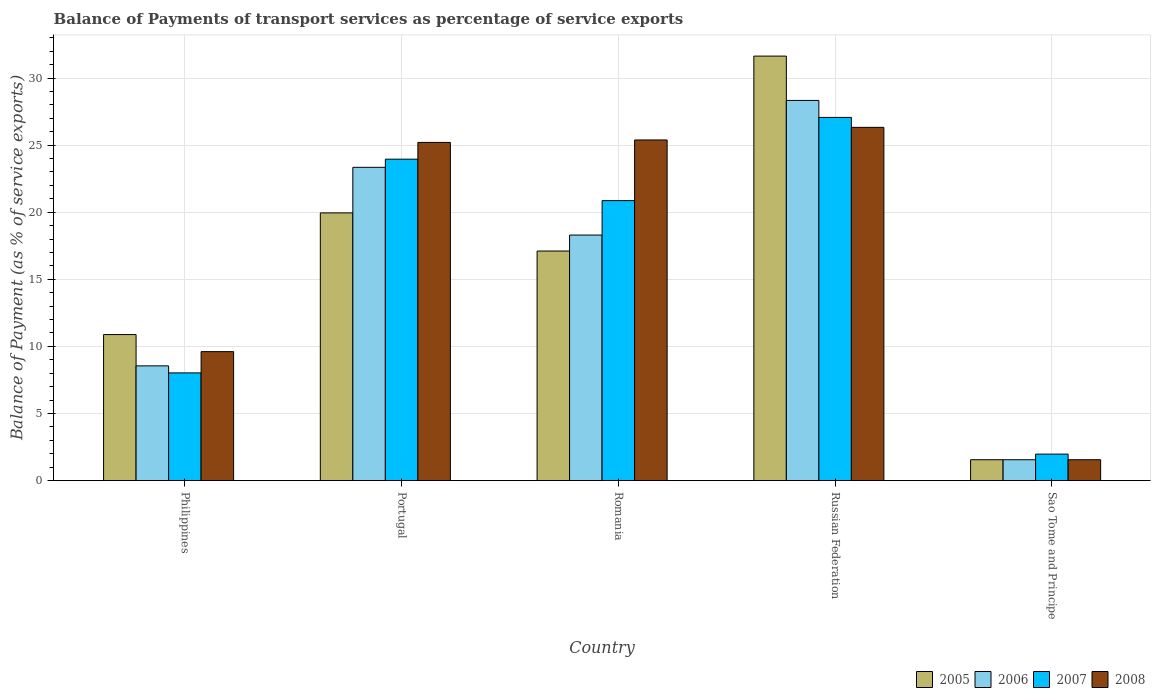How many different coloured bars are there?
Keep it short and to the point. 4. How many groups of bars are there?
Offer a very short reply. 5. How many bars are there on the 5th tick from the left?
Make the answer very short. 4. How many bars are there on the 1st tick from the right?
Offer a terse response. 4. What is the label of the 2nd group of bars from the left?
Offer a very short reply. Portugal. What is the balance of payments of transport services in 2007 in Russian Federation?
Ensure brevity in your answer.  27.06. Across all countries, what is the maximum balance of payments of transport services in 2006?
Make the answer very short. 28.33. Across all countries, what is the minimum balance of payments of transport services in 2006?
Your response must be concise. 1.55. In which country was the balance of payments of transport services in 2006 maximum?
Keep it short and to the point. Russian Federation. In which country was the balance of payments of transport services in 2005 minimum?
Provide a short and direct response. Sao Tome and Principe. What is the total balance of payments of transport services in 2007 in the graph?
Your answer should be compact. 81.87. What is the difference between the balance of payments of transport services in 2007 in Philippines and that in Russian Federation?
Offer a very short reply. -19.04. What is the difference between the balance of payments of transport services in 2007 in Portugal and the balance of payments of transport services in 2008 in Russian Federation?
Provide a short and direct response. -2.37. What is the average balance of payments of transport services in 2006 per country?
Your answer should be very brief. 16.01. What is the difference between the balance of payments of transport services of/in 2008 and balance of payments of transport services of/in 2006 in Sao Tome and Principe?
Your answer should be compact. 1.664999249584298e-10. What is the ratio of the balance of payments of transport services in 2007 in Portugal to that in Russian Federation?
Give a very brief answer. 0.89. Is the difference between the balance of payments of transport services in 2008 in Romania and Russian Federation greater than the difference between the balance of payments of transport services in 2006 in Romania and Russian Federation?
Keep it short and to the point. Yes. What is the difference between the highest and the second highest balance of payments of transport services in 2005?
Your response must be concise. -2.84. What is the difference between the highest and the lowest balance of payments of transport services in 2006?
Provide a succinct answer. 26.77. Is the sum of the balance of payments of transport services in 2006 in Portugal and Russian Federation greater than the maximum balance of payments of transport services in 2005 across all countries?
Your response must be concise. Yes. Is it the case that in every country, the sum of the balance of payments of transport services in 2007 and balance of payments of transport services in 2008 is greater than the sum of balance of payments of transport services in 2006 and balance of payments of transport services in 2005?
Provide a succinct answer. No. Is it the case that in every country, the sum of the balance of payments of transport services in 2005 and balance of payments of transport services in 2008 is greater than the balance of payments of transport services in 2006?
Ensure brevity in your answer.  Yes. How many bars are there?
Provide a short and direct response. 20. Are all the bars in the graph horizontal?
Keep it short and to the point. No. How many countries are there in the graph?
Keep it short and to the point. 5. Are the values on the major ticks of Y-axis written in scientific E-notation?
Make the answer very short. No. Does the graph contain any zero values?
Your response must be concise. No. How many legend labels are there?
Your answer should be compact. 4. How are the legend labels stacked?
Your response must be concise. Horizontal. What is the title of the graph?
Your response must be concise. Balance of Payments of transport services as percentage of service exports. What is the label or title of the Y-axis?
Keep it short and to the point. Balance of Payment (as % of service exports). What is the Balance of Payment (as % of service exports) of 2005 in Philippines?
Keep it short and to the point. 10.88. What is the Balance of Payment (as % of service exports) of 2006 in Philippines?
Give a very brief answer. 8.55. What is the Balance of Payment (as % of service exports) in 2007 in Philippines?
Your answer should be compact. 8.02. What is the Balance of Payment (as % of service exports) in 2008 in Philippines?
Give a very brief answer. 9.61. What is the Balance of Payment (as % of service exports) of 2005 in Portugal?
Your response must be concise. 19.95. What is the Balance of Payment (as % of service exports) of 2006 in Portugal?
Offer a very short reply. 23.34. What is the Balance of Payment (as % of service exports) of 2007 in Portugal?
Your answer should be compact. 23.95. What is the Balance of Payment (as % of service exports) in 2008 in Portugal?
Give a very brief answer. 25.2. What is the Balance of Payment (as % of service exports) in 2005 in Romania?
Provide a succinct answer. 17.11. What is the Balance of Payment (as % of service exports) of 2006 in Romania?
Give a very brief answer. 18.3. What is the Balance of Payment (as % of service exports) in 2007 in Romania?
Make the answer very short. 20.86. What is the Balance of Payment (as % of service exports) of 2008 in Romania?
Your answer should be compact. 25.38. What is the Balance of Payment (as % of service exports) in 2005 in Russian Federation?
Give a very brief answer. 31.63. What is the Balance of Payment (as % of service exports) of 2006 in Russian Federation?
Provide a succinct answer. 28.33. What is the Balance of Payment (as % of service exports) in 2007 in Russian Federation?
Your answer should be very brief. 27.06. What is the Balance of Payment (as % of service exports) in 2008 in Russian Federation?
Your answer should be very brief. 26.32. What is the Balance of Payment (as % of service exports) of 2005 in Sao Tome and Principe?
Offer a very short reply. 1.55. What is the Balance of Payment (as % of service exports) in 2006 in Sao Tome and Principe?
Your answer should be very brief. 1.55. What is the Balance of Payment (as % of service exports) of 2007 in Sao Tome and Principe?
Offer a very short reply. 1.97. What is the Balance of Payment (as % of service exports) of 2008 in Sao Tome and Principe?
Make the answer very short. 1.55. Across all countries, what is the maximum Balance of Payment (as % of service exports) of 2005?
Your response must be concise. 31.63. Across all countries, what is the maximum Balance of Payment (as % of service exports) of 2006?
Ensure brevity in your answer.  28.33. Across all countries, what is the maximum Balance of Payment (as % of service exports) in 2007?
Your answer should be compact. 27.06. Across all countries, what is the maximum Balance of Payment (as % of service exports) in 2008?
Your response must be concise. 26.32. Across all countries, what is the minimum Balance of Payment (as % of service exports) of 2005?
Your response must be concise. 1.55. Across all countries, what is the minimum Balance of Payment (as % of service exports) in 2006?
Make the answer very short. 1.55. Across all countries, what is the minimum Balance of Payment (as % of service exports) in 2007?
Offer a terse response. 1.97. Across all countries, what is the minimum Balance of Payment (as % of service exports) in 2008?
Provide a succinct answer. 1.55. What is the total Balance of Payment (as % of service exports) of 2005 in the graph?
Keep it short and to the point. 81.12. What is the total Balance of Payment (as % of service exports) of 2006 in the graph?
Provide a short and direct response. 80.07. What is the total Balance of Payment (as % of service exports) of 2007 in the graph?
Provide a short and direct response. 81.87. What is the total Balance of Payment (as % of service exports) of 2008 in the graph?
Your answer should be very brief. 88.07. What is the difference between the Balance of Payment (as % of service exports) in 2005 in Philippines and that in Portugal?
Offer a very short reply. -9.07. What is the difference between the Balance of Payment (as % of service exports) in 2006 in Philippines and that in Portugal?
Ensure brevity in your answer.  -14.8. What is the difference between the Balance of Payment (as % of service exports) in 2007 in Philippines and that in Portugal?
Give a very brief answer. -15.93. What is the difference between the Balance of Payment (as % of service exports) in 2008 in Philippines and that in Portugal?
Ensure brevity in your answer.  -15.59. What is the difference between the Balance of Payment (as % of service exports) of 2005 in Philippines and that in Romania?
Offer a very short reply. -6.23. What is the difference between the Balance of Payment (as % of service exports) of 2006 in Philippines and that in Romania?
Offer a very short reply. -9.75. What is the difference between the Balance of Payment (as % of service exports) in 2007 in Philippines and that in Romania?
Your response must be concise. -12.84. What is the difference between the Balance of Payment (as % of service exports) in 2008 in Philippines and that in Romania?
Ensure brevity in your answer.  -15.77. What is the difference between the Balance of Payment (as % of service exports) of 2005 in Philippines and that in Russian Federation?
Your response must be concise. -20.75. What is the difference between the Balance of Payment (as % of service exports) in 2006 in Philippines and that in Russian Federation?
Offer a terse response. -19.78. What is the difference between the Balance of Payment (as % of service exports) in 2007 in Philippines and that in Russian Federation?
Give a very brief answer. -19.04. What is the difference between the Balance of Payment (as % of service exports) in 2008 in Philippines and that in Russian Federation?
Your answer should be very brief. -16.71. What is the difference between the Balance of Payment (as % of service exports) in 2005 in Philippines and that in Sao Tome and Principe?
Offer a terse response. 9.33. What is the difference between the Balance of Payment (as % of service exports) of 2006 in Philippines and that in Sao Tome and Principe?
Your answer should be compact. 6.99. What is the difference between the Balance of Payment (as % of service exports) in 2007 in Philippines and that in Sao Tome and Principe?
Your response must be concise. 6.05. What is the difference between the Balance of Payment (as % of service exports) of 2008 in Philippines and that in Sao Tome and Principe?
Your answer should be compact. 8.06. What is the difference between the Balance of Payment (as % of service exports) in 2005 in Portugal and that in Romania?
Ensure brevity in your answer.  2.84. What is the difference between the Balance of Payment (as % of service exports) of 2006 in Portugal and that in Romania?
Your answer should be very brief. 5.05. What is the difference between the Balance of Payment (as % of service exports) of 2007 in Portugal and that in Romania?
Make the answer very short. 3.09. What is the difference between the Balance of Payment (as % of service exports) of 2008 in Portugal and that in Romania?
Provide a short and direct response. -0.18. What is the difference between the Balance of Payment (as % of service exports) of 2005 in Portugal and that in Russian Federation?
Keep it short and to the point. -11.68. What is the difference between the Balance of Payment (as % of service exports) in 2006 in Portugal and that in Russian Federation?
Provide a short and direct response. -4.98. What is the difference between the Balance of Payment (as % of service exports) in 2007 in Portugal and that in Russian Federation?
Offer a terse response. -3.11. What is the difference between the Balance of Payment (as % of service exports) in 2008 in Portugal and that in Russian Federation?
Your response must be concise. -1.12. What is the difference between the Balance of Payment (as % of service exports) of 2005 in Portugal and that in Sao Tome and Principe?
Your response must be concise. 18.39. What is the difference between the Balance of Payment (as % of service exports) in 2006 in Portugal and that in Sao Tome and Principe?
Offer a terse response. 21.79. What is the difference between the Balance of Payment (as % of service exports) in 2007 in Portugal and that in Sao Tome and Principe?
Give a very brief answer. 21.98. What is the difference between the Balance of Payment (as % of service exports) in 2008 in Portugal and that in Sao Tome and Principe?
Provide a succinct answer. 23.65. What is the difference between the Balance of Payment (as % of service exports) in 2005 in Romania and that in Russian Federation?
Your response must be concise. -14.53. What is the difference between the Balance of Payment (as % of service exports) of 2006 in Romania and that in Russian Federation?
Make the answer very short. -10.03. What is the difference between the Balance of Payment (as % of service exports) in 2007 in Romania and that in Russian Federation?
Ensure brevity in your answer.  -6.2. What is the difference between the Balance of Payment (as % of service exports) in 2008 in Romania and that in Russian Federation?
Offer a terse response. -0.94. What is the difference between the Balance of Payment (as % of service exports) of 2005 in Romania and that in Sao Tome and Principe?
Give a very brief answer. 15.55. What is the difference between the Balance of Payment (as % of service exports) of 2006 in Romania and that in Sao Tome and Principe?
Your response must be concise. 16.74. What is the difference between the Balance of Payment (as % of service exports) in 2007 in Romania and that in Sao Tome and Principe?
Ensure brevity in your answer.  18.89. What is the difference between the Balance of Payment (as % of service exports) in 2008 in Romania and that in Sao Tome and Principe?
Give a very brief answer. 23.83. What is the difference between the Balance of Payment (as % of service exports) of 2005 in Russian Federation and that in Sao Tome and Principe?
Provide a short and direct response. 30.08. What is the difference between the Balance of Payment (as % of service exports) of 2006 in Russian Federation and that in Sao Tome and Principe?
Make the answer very short. 26.77. What is the difference between the Balance of Payment (as % of service exports) in 2007 in Russian Federation and that in Sao Tome and Principe?
Keep it short and to the point. 25.09. What is the difference between the Balance of Payment (as % of service exports) in 2008 in Russian Federation and that in Sao Tome and Principe?
Provide a short and direct response. 24.77. What is the difference between the Balance of Payment (as % of service exports) in 2005 in Philippines and the Balance of Payment (as % of service exports) in 2006 in Portugal?
Ensure brevity in your answer.  -12.46. What is the difference between the Balance of Payment (as % of service exports) of 2005 in Philippines and the Balance of Payment (as % of service exports) of 2007 in Portugal?
Offer a terse response. -13.07. What is the difference between the Balance of Payment (as % of service exports) in 2005 in Philippines and the Balance of Payment (as % of service exports) in 2008 in Portugal?
Provide a short and direct response. -14.32. What is the difference between the Balance of Payment (as % of service exports) in 2006 in Philippines and the Balance of Payment (as % of service exports) in 2007 in Portugal?
Make the answer very short. -15.4. What is the difference between the Balance of Payment (as % of service exports) in 2006 in Philippines and the Balance of Payment (as % of service exports) in 2008 in Portugal?
Your answer should be very brief. -16.65. What is the difference between the Balance of Payment (as % of service exports) of 2007 in Philippines and the Balance of Payment (as % of service exports) of 2008 in Portugal?
Your response must be concise. -17.18. What is the difference between the Balance of Payment (as % of service exports) of 2005 in Philippines and the Balance of Payment (as % of service exports) of 2006 in Romania?
Your response must be concise. -7.42. What is the difference between the Balance of Payment (as % of service exports) of 2005 in Philippines and the Balance of Payment (as % of service exports) of 2007 in Romania?
Offer a very short reply. -9.98. What is the difference between the Balance of Payment (as % of service exports) of 2005 in Philippines and the Balance of Payment (as % of service exports) of 2008 in Romania?
Provide a short and direct response. -14.5. What is the difference between the Balance of Payment (as % of service exports) in 2006 in Philippines and the Balance of Payment (as % of service exports) in 2007 in Romania?
Keep it short and to the point. -12.32. What is the difference between the Balance of Payment (as % of service exports) of 2006 in Philippines and the Balance of Payment (as % of service exports) of 2008 in Romania?
Your answer should be very brief. -16.84. What is the difference between the Balance of Payment (as % of service exports) of 2007 in Philippines and the Balance of Payment (as % of service exports) of 2008 in Romania?
Offer a very short reply. -17.36. What is the difference between the Balance of Payment (as % of service exports) of 2005 in Philippines and the Balance of Payment (as % of service exports) of 2006 in Russian Federation?
Provide a short and direct response. -17.45. What is the difference between the Balance of Payment (as % of service exports) in 2005 in Philippines and the Balance of Payment (as % of service exports) in 2007 in Russian Federation?
Offer a terse response. -16.18. What is the difference between the Balance of Payment (as % of service exports) of 2005 in Philippines and the Balance of Payment (as % of service exports) of 2008 in Russian Federation?
Offer a very short reply. -15.44. What is the difference between the Balance of Payment (as % of service exports) in 2006 in Philippines and the Balance of Payment (as % of service exports) in 2007 in Russian Federation?
Provide a succinct answer. -18.51. What is the difference between the Balance of Payment (as % of service exports) in 2006 in Philippines and the Balance of Payment (as % of service exports) in 2008 in Russian Federation?
Offer a terse response. -17.77. What is the difference between the Balance of Payment (as % of service exports) of 2007 in Philippines and the Balance of Payment (as % of service exports) of 2008 in Russian Federation?
Keep it short and to the point. -18.3. What is the difference between the Balance of Payment (as % of service exports) of 2005 in Philippines and the Balance of Payment (as % of service exports) of 2006 in Sao Tome and Principe?
Offer a terse response. 9.33. What is the difference between the Balance of Payment (as % of service exports) in 2005 in Philippines and the Balance of Payment (as % of service exports) in 2007 in Sao Tome and Principe?
Offer a terse response. 8.91. What is the difference between the Balance of Payment (as % of service exports) in 2005 in Philippines and the Balance of Payment (as % of service exports) in 2008 in Sao Tome and Principe?
Your answer should be very brief. 9.33. What is the difference between the Balance of Payment (as % of service exports) of 2006 in Philippines and the Balance of Payment (as % of service exports) of 2007 in Sao Tome and Principe?
Offer a very short reply. 6.58. What is the difference between the Balance of Payment (as % of service exports) of 2006 in Philippines and the Balance of Payment (as % of service exports) of 2008 in Sao Tome and Principe?
Keep it short and to the point. 6.99. What is the difference between the Balance of Payment (as % of service exports) of 2007 in Philippines and the Balance of Payment (as % of service exports) of 2008 in Sao Tome and Principe?
Keep it short and to the point. 6.47. What is the difference between the Balance of Payment (as % of service exports) in 2005 in Portugal and the Balance of Payment (as % of service exports) in 2006 in Romania?
Your answer should be very brief. 1.65. What is the difference between the Balance of Payment (as % of service exports) in 2005 in Portugal and the Balance of Payment (as % of service exports) in 2007 in Romania?
Your answer should be compact. -0.91. What is the difference between the Balance of Payment (as % of service exports) of 2005 in Portugal and the Balance of Payment (as % of service exports) of 2008 in Romania?
Make the answer very short. -5.43. What is the difference between the Balance of Payment (as % of service exports) in 2006 in Portugal and the Balance of Payment (as % of service exports) in 2007 in Romania?
Give a very brief answer. 2.48. What is the difference between the Balance of Payment (as % of service exports) of 2006 in Portugal and the Balance of Payment (as % of service exports) of 2008 in Romania?
Offer a very short reply. -2.04. What is the difference between the Balance of Payment (as % of service exports) of 2007 in Portugal and the Balance of Payment (as % of service exports) of 2008 in Romania?
Offer a terse response. -1.43. What is the difference between the Balance of Payment (as % of service exports) in 2005 in Portugal and the Balance of Payment (as % of service exports) in 2006 in Russian Federation?
Give a very brief answer. -8.38. What is the difference between the Balance of Payment (as % of service exports) in 2005 in Portugal and the Balance of Payment (as % of service exports) in 2007 in Russian Federation?
Provide a succinct answer. -7.11. What is the difference between the Balance of Payment (as % of service exports) of 2005 in Portugal and the Balance of Payment (as % of service exports) of 2008 in Russian Federation?
Give a very brief answer. -6.37. What is the difference between the Balance of Payment (as % of service exports) of 2006 in Portugal and the Balance of Payment (as % of service exports) of 2007 in Russian Federation?
Provide a short and direct response. -3.72. What is the difference between the Balance of Payment (as % of service exports) of 2006 in Portugal and the Balance of Payment (as % of service exports) of 2008 in Russian Federation?
Provide a short and direct response. -2.98. What is the difference between the Balance of Payment (as % of service exports) of 2007 in Portugal and the Balance of Payment (as % of service exports) of 2008 in Russian Federation?
Provide a short and direct response. -2.37. What is the difference between the Balance of Payment (as % of service exports) in 2005 in Portugal and the Balance of Payment (as % of service exports) in 2006 in Sao Tome and Principe?
Your answer should be very brief. 18.39. What is the difference between the Balance of Payment (as % of service exports) in 2005 in Portugal and the Balance of Payment (as % of service exports) in 2007 in Sao Tome and Principe?
Your answer should be very brief. 17.98. What is the difference between the Balance of Payment (as % of service exports) in 2005 in Portugal and the Balance of Payment (as % of service exports) in 2008 in Sao Tome and Principe?
Give a very brief answer. 18.39. What is the difference between the Balance of Payment (as % of service exports) of 2006 in Portugal and the Balance of Payment (as % of service exports) of 2007 in Sao Tome and Principe?
Make the answer very short. 21.37. What is the difference between the Balance of Payment (as % of service exports) of 2006 in Portugal and the Balance of Payment (as % of service exports) of 2008 in Sao Tome and Principe?
Your answer should be compact. 21.79. What is the difference between the Balance of Payment (as % of service exports) in 2007 in Portugal and the Balance of Payment (as % of service exports) in 2008 in Sao Tome and Principe?
Offer a very short reply. 22.4. What is the difference between the Balance of Payment (as % of service exports) in 2005 in Romania and the Balance of Payment (as % of service exports) in 2006 in Russian Federation?
Keep it short and to the point. -11.22. What is the difference between the Balance of Payment (as % of service exports) in 2005 in Romania and the Balance of Payment (as % of service exports) in 2007 in Russian Federation?
Make the answer very short. -9.96. What is the difference between the Balance of Payment (as % of service exports) in 2005 in Romania and the Balance of Payment (as % of service exports) in 2008 in Russian Federation?
Provide a short and direct response. -9.22. What is the difference between the Balance of Payment (as % of service exports) of 2006 in Romania and the Balance of Payment (as % of service exports) of 2007 in Russian Federation?
Make the answer very short. -8.77. What is the difference between the Balance of Payment (as % of service exports) of 2006 in Romania and the Balance of Payment (as % of service exports) of 2008 in Russian Federation?
Your answer should be compact. -8.03. What is the difference between the Balance of Payment (as % of service exports) of 2007 in Romania and the Balance of Payment (as % of service exports) of 2008 in Russian Federation?
Ensure brevity in your answer.  -5.46. What is the difference between the Balance of Payment (as % of service exports) of 2005 in Romania and the Balance of Payment (as % of service exports) of 2006 in Sao Tome and Principe?
Provide a short and direct response. 15.55. What is the difference between the Balance of Payment (as % of service exports) in 2005 in Romania and the Balance of Payment (as % of service exports) in 2007 in Sao Tome and Principe?
Your answer should be very brief. 15.14. What is the difference between the Balance of Payment (as % of service exports) in 2005 in Romania and the Balance of Payment (as % of service exports) in 2008 in Sao Tome and Principe?
Your response must be concise. 15.55. What is the difference between the Balance of Payment (as % of service exports) in 2006 in Romania and the Balance of Payment (as % of service exports) in 2007 in Sao Tome and Principe?
Provide a short and direct response. 16.32. What is the difference between the Balance of Payment (as % of service exports) of 2006 in Romania and the Balance of Payment (as % of service exports) of 2008 in Sao Tome and Principe?
Offer a very short reply. 16.74. What is the difference between the Balance of Payment (as % of service exports) in 2007 in Romania and the Balance of Payment (as % of service exports) in 2008 in Sao Tome and Principe?
Offer a terse response. 19.31. What is the difference between the Balance of Payment (as % of service exports) of 2005 in Russian Federation and the Balance of Payment (as % of service exports) of 2006 in Sao Tome and Principe?
Ensure brevity in your answer.  30.08. What is the difference between the Balance of Payment (as % of service exports) in 2005 in Russian Federation and the Balance of Payment (as % of service exports) in 2007 in Sao Tome and Principe?
Your response must be concise. 29.66. What is the difference between the Balance of Payment (as % of service exports) in 2005 in Russian Federation and the Balance of Payment (as % of service exports) in 2008 in Sao Tome and Principe?
Provide a succinct answer. 30.08. What is the difference between the Balance of Payment (as % of service exports) of 2006 in Russian Federation and the Balance of Payment (as % of service exports) of 2007 in Sao Tome and Principe?
Your response must be concise. 26.36. What is the difference between the Balance of Payment (as % of service exports) in 2006 in Russian Federation and the Balance of Payment (as % of service exports) in 2008 in Sao Tome and Principe?
Ensure brevity in your answer.  26.77. What is the difference between the Balance of Payment (as % of service exports) in 2007 in Russian Federation and the Balance of Payment (as % of service exports) in 2008 in Sao Tome and Principe?
Offer a very short reply. 25.51. What is the average Balance of Payment (as % of service exports) in 2005 per country?
Ensure brevity in your answer.  16.22. What is the average Balance of Payment (as % of service exports) in 2006 per country?
Provide a succinct answer. 16.01. What is the average Balance of Payment (as % of service exports) of 2007 per country?
Your answer should be compact. 16.37. What is the average Balance of Payment (as % of service exports) in 2008 per country?
Your answer should be compact. 17.61. What is the difference between the Balance of Payment (as % of service exports) of 2005 and Balance of Payment (as % of service exports) of 2006 in Philippines?
Provide a succinct answer. 2.33. What is the difference between the Balance of Payment (as % of service exports) of 2005 and Balance of Payment (as % of service exports) of 2007 in Philippines?
Provide a succinct answer. 2.86. What is the difference between the Balance of Payment (as % of service exports) in 2005 and Balance of Payment (as % of service exports) in 2008 in Philippines?
Your answer should be compact. 1.27. What is the difference between the Balance of Payment (as % of service exports) of 2006 and Balance of Payment (as % of service exports) of 2007 in Philippines?
Your response must be concise. 0.52. What is the difference between the Balance of Payment (as % of service exports) in 2006 and Balance of Payment (as % of service exports) in 2008 in Philippines?
Give a very brief answer. -1.06. What is the difference between the Balance of Payment (as % of service exports) of 2007 and Balance of Payment (as % of service exports) of 2008 in Philippines?
Your answer should be compact. -1.58. What is the difference between the Balance of Payment (as % of service exports) in 2005 and Balance of Payment (as % of service exports) in 2006 in Portugal?
Give a very brief answer. -3.4. What is the difference between the Balance of Payment (as % of service exports) in 2005 and Balance of Payment (as % of service exports) in 2007 in Portugal?
Offer a very short reply. -4. What is the difference between the Balance of Payment (as % of service exports) in 2005 and Balance of Payment (as % of service exports) in 2008 in Portugal?
Provide a succinct answer. -5.25. What is the difference between the Balance of Payment (as % of service exports) of 2006 and Balance of Payment (as % of service exports) of 2007 in Portugal?
Your response must be concise. -0.61. What is the difference between the Balance of Payment (as % of service exports) of 2006 and Balance of Payment (as % of service exports) of 2008 in Portugal?
Offer a very short reply. -1.86. What is the difference between the Balance of Payment (as % of service exports) of 2007 and Balance of Payment (as % of service exports) of 2008 in Portugal?
Your answer should be very brief. -1.25. What is the difference between the Balance of Payment (as % of service exports) in 2005 and Balance of Payment (as % of service exports) in 2006 in Romania?
Make the answer very short. -1.19. What is the difference between the Balance of Payment (as % of service exports) in 2005 and Balance of Payment (as % of service exports) in 2007 in Romania?
Offer a terse response. -3.76. What is the difference between the Balance of Payment (as % of service exports) of 2005 and Balance of Payment (as % of service exports) of 2008 in Romania?
Ensure brevity in your answer.  -8.28. What is the difference between the Balance of Payment (as % of service exports) in 2006 and Balance of Payment (as % of service exports) in 2007 in Romania?
Ensure brevity in your answer.  -2.57. What is the difference between the Balance of Payment (as % of service exports) in 2006 and Balance of Payment (as % of service exports) in 2008 in Romania?
Provide a short and direct response. -7.09. What is the difference between the Balance of Payment (as % of service exports) in 2007 and Balance of Payment (as % of service exports) in 2008 in Romania?
Your answer should be very brief. -4.52. What is the difference between the Balance of Payment (as % of service exports) in 2005 and Balance of Payment (as % of service exports) in 2006 in Russian Federation?
Offer a terse response. 3.3. What is the difference between the Balance of Payment (as % of service exports) of 2005 and Balance of Payment (as % of service exports) of 2007 in Russian Federation?
Give a very brief answer. 4.57. What is the difference between the Balance of Payment (as % of service exports) of 2005 and Balance of Payment (as % of service exports) of 2008 in Russian Federation?
Your answer should be very brief. 5.31. What is the difference between the Balance of Payment (as % of service exports) of 2006 and Balance of Payment (as % of service exports) of 2007 in Russian Federation?
Make the answer very short. 1.27. What is the difference between the Balance of Payment (as % of service exports) in 2006 and Balance of Payment (as % of service exports) in 2008 in Russian Federation?
Provide a succinct answer. 2.01. What is the difference between the Balance of Payment (as % of service exports) of 2007 and Balance of Payment (as % of service exports) of 2008 in Russian Federation?
Offer a very short reply. 0.74. What is the difference between the Balance of Payment (as % of service exports) in 2005 and Balance of Payment (as % of service exports) in 2006 in Sao Tome and Principe?
Offer a very short reply. 0. What is the difference between the Balance of Payment (as % of service exports) in 2005 and Balance of Payment (as % of service exports) in 2007 in Sao Tome and Principe?
Offer a terse response. -0.42. What is the difference between the Balance of Payment (as % of service exports) in 2005 and Balance of Payment (as % of service exports) in 2008 in Sao Tome and Principe?
Provide a succinct answer. 0. What is the difference between the Balance of Payment (as % of service exports) of 2006 and Balance of Payment (as % of service exports) of 2007 in Sao Tome and Principe?
Ensure brevity in your answer.  -0.42. What is the difference between the Balance of Payment (as % of service exports) of 2006 and Balance of Payment (as % of service exports) of 2008 in Sao Tome and Principe?
Offer a very short reply. -0. What is the difference between the Balance of Payment (as % of service exports) in 2007 and Balance of Payment (as % of service exports) in 2008 in Sao Tome and Principe?
Your response must be concise. 0.42. What is the ratio of the Balance of Payment (as % of service exports) of 2005 in Philippines to that in Portugal?
Your response must be concise. 0.55. What is the ratio of the Balance of Payment (as % of service exports) of 2006 in Philippines to that in Portugal?
Offer a very short reply. 0.37. What is the ratio of the Balance of Payment (as % of service exports) of 2007 in Philippines to that in Portugal?
Provide a short and direct response. 0.34. What is the ratio of the Balance of Payment (as % of service exports) in 2008 in Philippines to that in Portugal?
Your response must be concise. 0.38. What is the ratio of the Balance of Payment (as % of service exports) in 2005 in Philippines to that in Romania?
Give a very brief answer. 0.64. What is the ratio of the Balance of Payment (as % of service exports) in 2006 in Philippines to that in Romania?
Give a very brief answer. 0.47. What is the ratio of the Balance of Payment (as % of service exports) in 2007 in Philippines to that in Romania?
Ensure brevity in your answer.  0.38. What is the ratio of the Balance of Payment (as % of service exports) of 2008 in Philippines to that in Romania?
Your answer should be compact. 0.38. What is the ratio of the Balance of Payment (as % of service exports) in 2005 in Philippines to that in Russian Federation?
Your answer should be compact. 0.34. What is the ratio of the Balance of Payment (as % of service exports) of 2006 in Philippines to that in Russian Federation?
Offer a very short reply. 0.3. What is the ratio of the Balance of Payment (as % of service exports) in 2007 in Philippines to that in Russian Federation?
Offer a very short reply. 0.3. What is the ratio of the Balance of Payment (as % of service exports) in 2008 in Philippines to that in Russian Federation?
Offer a very short reply. 0.37. What is the ratio of the Balance of Payment (as % of service exports) in 2005 in Philippines to that in Sao Tome and Principe?
Your response must be concise. 7. What is the ratio of the Balance of Payment (as % of service exports) of 2006 in Philippines to that in Sao Tome and Principe?
Your response must be concise. 5.5. What is the ratio of the Balance of Payment (as % of service exports) of 2007 in Philippines to that in Sao Tome and Principe?
Keep it short and to the point. 4.07. What is the ratio of the Balance of Payment (as % of service exports) in 2008 in Philippines to that in Sao Tome and Principe?
Your response must be concise. 6.18. What is the ratio of the Balance of Payment (as % of service exports) in 2005 in Portugal to that in Romania?
Your answer should be compact. 1.17. What is the ratio of the Balance of Payment (as % of service exports) in 2006 in Portugal to that in Romania?
Provide a succinct answer. 1.28. What is the ratio of the Balance of Payment (as % of service exports) of 2007 in Portugal to that in Romania?
Keep it short and to the point. 1.15. What is the ratio of the Balance of Payment (as % of service exports) in 2008 in Portugal to that in Romania?
Your answer should be very brief. 0.99. What is the ratio of the Balance of Payment (as % of service exports) of 2005 in Portugal to that in Russian Federation?
Make the answer very short. 0.63. What is the ratio of the Balance of Payment (as % of service exports) in 2006 in Portugal to that in Russian Federation?
Your response must be concise. 0.82. What is the ratio of the Balance of Payment (as % of service exports) in 2007 in Portugal to that in Russian Federation?
Keep it short and to the point. 0.89. What is the ratio of the Balance of Payment (as % of service exports) of 2008 in Portugal to that in Russian Federation?
Offer a terse response. 0.96. What is the ratio of the Balance of Payment (as % of service exports) in 2005 in Portugal to that in Sao Tome and Principe?
Provide a succinct answer. 12.84. What is the ratio of the Balance of Payment (as % of service exports) of 2006 in Portugal to that in Sao Tome and Principe?
Keep it short and to the point. 15.02. What is the ratio of the Balance of Payment (as % of service exports) in 2007 in Portugal to that in Sao Tome and Principe?
Keep it short and to the point. 12.15. What is the ratio of the Balance of Payment (as % of service exports) of 2008 in Portugal to that in Sao Tome and Principe?
Provide a short and direct response. 16.22. What is the ratio of the Balance of Payment (as % of service exports) of 2005 in Romania to that in Russian Federation?
Give a very brief answer. 0.54. What is the ratio of the Balance of Payment (as % of service exports) of 2006 in Romania to that in Russian Federation?
Provide a succinct answer. 0.65. What is the ratio of the Balance of Payment (as % of service exports) of 2007 in Romania to that in Russian Federation?
Provide a short and direct response. 0.77. What is the ratio of the Balance of Payment (as % of service exports) in 2008 in Romania to that in Russian Federation?
Offer a very short reply. 0.96. What is the ratio of the Balance of Payment (as % of service exports) of 2005 in Romania to that in Sao Tome and Principe?
Make the answer very short. 11.01. What is the ratio of the Balance of Payment (as % of service exports) in 2006 in Romania to that in Sao Tome and Principe?
Give a very brief answer. 11.77. What is the ratio of the Balance of Payment (as % of service exports) in 2007 in Romania to that in Sao Tome and Principe?
Give a very brief answer. 10.58. What is the ratio of the Balance of Payment (as % of service exports) of 2008 in Romania to that in Sao Tome and Principe?
Your answer should be very brief. 16.33. What is the ratio of the Balance of Payment (as % of service exports) in 2005 in Russian Federation to that in Sao Tome and Principe?
Provide a succinct answer. 20.36. What is the ratio of the Balance of Payment (as % of service exports) in 2006 in Russian Federation to that in Sao Tome and Principe?
Give a very brief answer. 18.23. What is the ratio of the Balance of Payment (as % of service exports) of 2007 in Russian Federation to that in Sao Tome and Principe?
Provide a succinct answer. 13.73. What is the ratio of the Balance of Payment (as % of service exports) in 2008 in Russian Federation to that in Sao Tome and Principe?
Make the answer very short. 16.94. What is the difference between the highest and the second highest Balance of Payment (as % of service exports) in 2005?
Ensure brevity in your answer.  11.68. What is the difference between the highest and the second highest Balance of Payment (as % of service exports) in 2006?
Your answer should be compact. 4.98. What is the difference between the highest and the second highest Balance of Payment (as % of service exports) in 2007?
Your answer should be very brief. 3.11. What is the difference between the highest and the second highest Balance of Payment (as % of service exports) of 2008?
Ensure brevity in your answer.  0.94. What is the difference between the highest and the lowest Balance of Payment (as % of service exports) in 2005?
Your answer should be very brief. 30.08. What is the difference between the highest and the lowest Balance of Payment (as % of service exports) in 2006?
Your response must be concise. 26.77. What is the difference between the highest and the lowest Balance of Payment (as % of service exports) of 2007?
Offer a terse response. 25.09. What is the difference between the highest and the lowest Balance of Payment (as % of service exports) in 2008?
Ensure brevity in your answer.  24.77. 